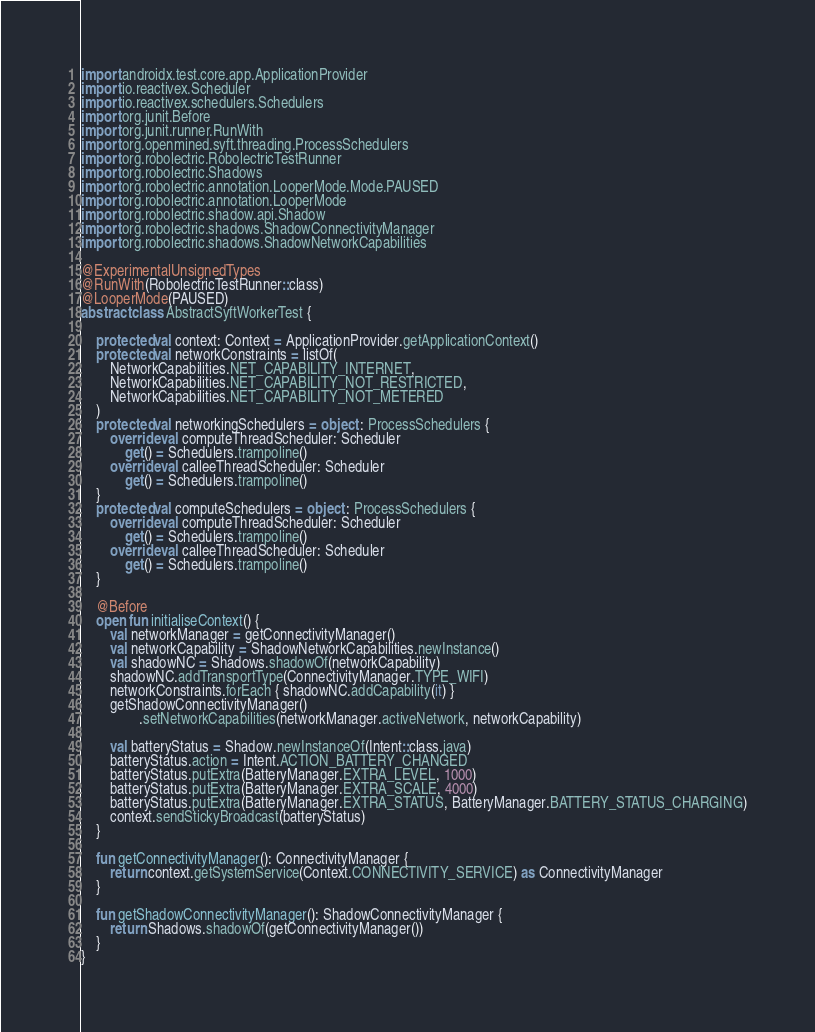Convert code to text. <code><loc_0><loc_0><loc_500><loc_500><_Kotlin_>import androidx.test.core.app.ApplicationProvider
import io.reactivex.Scheduler
import io.reactivex.schedulers.Schedulers
import org.junit.Before
import org.junit.runner.RunWith
import org.openmined.syft.threading.ProcessSchedulers
import org.robolectric.RobolectricTestRunner
import org.robolectric.Shadows
import org.robolectric.annotation.LooperMode.Mode.PAUSED
import org.robolectric.annotation.LooperMode
import org.robolectric.shadow.api.Shadow
import org.robolectric.shadows.ShadowConnectivityManager
import org.robolectric.shadows.ShadowNetworkCapabilities

@ExperimentalUnsignedTypes
@RunWith(RobolectricTestRunner::class)
@LooperMode(PAUSED)
abstract class AbstractSyftWorkerTest {

    protected val context: Context = ApplicationProvider.getApplicationContext()
    protected val networkConstraints = listOf(
        NetworkCapabilities.NET_CAPABILITY_INTERNET,
        NetworkCapabilities.NET_CAPABILITY_NOT_RESTRICTED,
        NetworkCapabilities.NET_CAPABILITY_NOT_METERED
    )
    protected val networkingSchedulers = object : ProcessSchedulers {
        override val computeThreadScheduler: Scheduler
            get() = Schedulers.trampoline()
        override val calleeThreadScheduler: Scheduler
            get() = Schedulers.trampoline()
    }
    protected val computeSchedulers = object : ProcessSchedulers {
        override val computeThreadScheduler: Scheduler
            get() = Schedulers.trampoline()
        override val calleeThreadScheduler: Scheduler
            get() = Schedulers.trampoline()
    }

    @Before
    open fun initialiseContext() {
        val networkManager = getConnectivityManager()
        val networkCapability = ShadowNetworkCapabilities.newInstance()
        val shadowNC = Shadows.shadowOf(networkCapability)
        shadowNC.addTransportType(ConnectivityManager.TYPE_WIFI)
        networkConstraints.forEach { shadowNC.addCapability(it) }
        getShadowConnectivityManager()
                .setNetworkCapabilities(networkManager.activeNetwork, networkCapability)

        val batteryStatus = Shadow.newInstanceOf(Intent::class.java)
        batteryStatus.action = Intent.ACTION_BATTERY_CHANGED
        batteryStatus.putExtra(BatteryManager.EXTRA_LEVEL, 1000)
        batteryStatus.putExtra(BatteryManager.EXTRA_SCALE, 4000)
        batteryStatus.putExtra(BatteryManager.EXTRA_STATUS, BatteryManager.BATTERY_STATUS_CHARGING)
        context.sendStickyBroadcast(batteryStatus)
    }

    fun getConnectivityManager(): ConnectivityManager {
        return context.getSystemService(Context.CONNECTIVITY_SERVICE) as ConnectivityManager
    }

    fun getShadowConnectivityManager(): ShadowConnectivityManager {
        return Shadows.shadowOf(getConnectivityManager())
    }
}</code> 